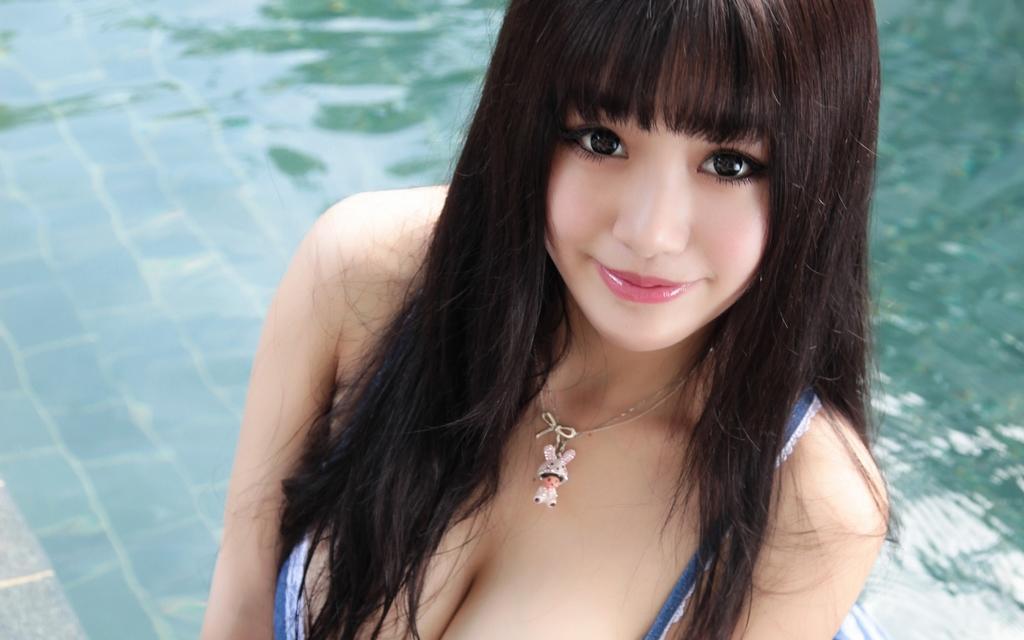How would you summarize this image in a sentence or two? In this image I can see the person wearing the blue and white color dress. In the background I can see the water. I can see the reflection of trees in the water. 